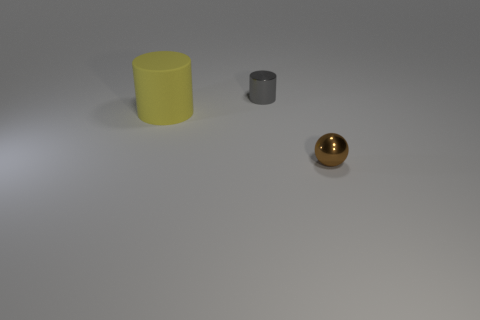Add 1 small cylinders. How many objects exist? 4 Subtract all cylinders. How many objects are left? 1 Add 1 small gray shiny cylinders. How many small gray shiny cylinders exist? 2 Subtract 0 blue cylinders. How many objects are left? 3 Subtract all cylinders. Subtract all big purple cylinders. How many objects are left? 1 Add 2 large rubber cylinders. How many large rubber cylinders are left? 3 